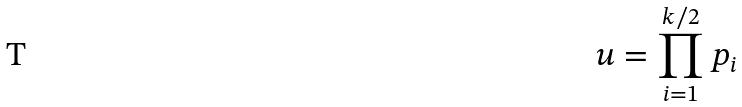Convert formula to latex. <formula><loc_0><loc_0><loc_500><loc_500>u = \prod _ { i = 1 } ^ { k / 2 } p _ { i }</formula> 